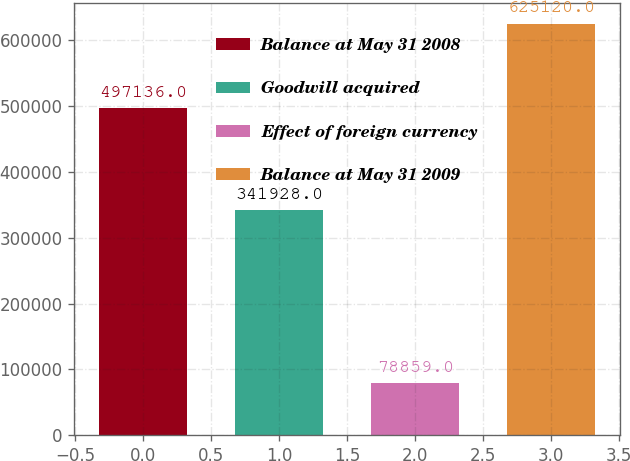Convert chart. <chart><loc_0><loc_0><loc_500><loc_500><bar_chart><fcel>Balance at May 31 2008<fcel>Goodwill acquired<fcel>Effect of foreign currency<fcel>Balance at May 31 2009<nl><fcel>497136<fcel>341928<fcel>78859<fcel>625120<nl></chart> 